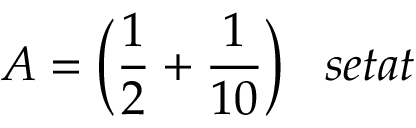<formula> <loc_0><loc_0><loc_500><loc_500>A = { \left ( } { \frac { 1 } { 2 } } + { \frac { 1 } { 1 0 } } { \right ) } \, s e t a t</formula> 